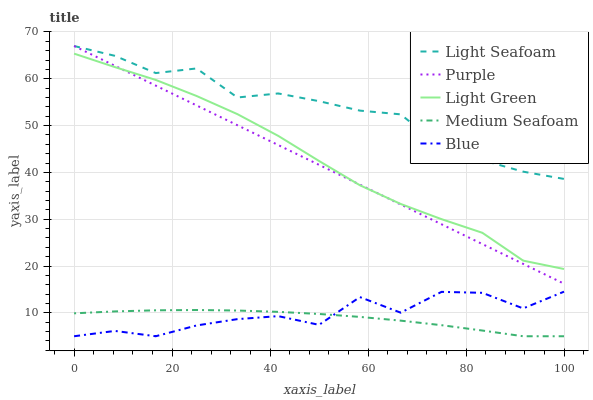Does Medium Seafoam have the minimum area under the curve?
Answer yes or no. Yes. Does Light Seafoam have the maximum area under the curve?
Answer yes or no. Yes. Does Blue have the minimum area under the curve?
Answer yes or no. No. Does Blue have the maximum area under the curve?
Answer yes or no. No. Is Purple the smoothest?
Answer yes or no. Yes. Is Blue the roughest?
Answer yes or no. Yes. Is Light Seafoam the smoothest?
Answer yes or no. No. Is Light Seafoam the roughest?
Answer yes or no. No. Does Blue have the lowest value?
Answer yes or no. Yes. Does Light Seafoam have the lowest value?
Answer yes or no. No. Does Light Seafoam have the highest value?
Answer yes or no. Yes. Does Blue have the highest value?
Answer yes or no. No. Is Light Green less than Light Seafoam?
Answer yes or no. Yes. Is Purple greater than Blue?
Answer yes or no. Yes. Does Medium Seafoam intersect Blue?
Answer yes or no. Yes. Is Medium Seafoam less than Blue?
Answer yes or no. No. Is Medium Seafoam greater than Blue?
Answer yes or no. No. Does Light Green intersect Light Seafoam?
Answer yes or no. No. 